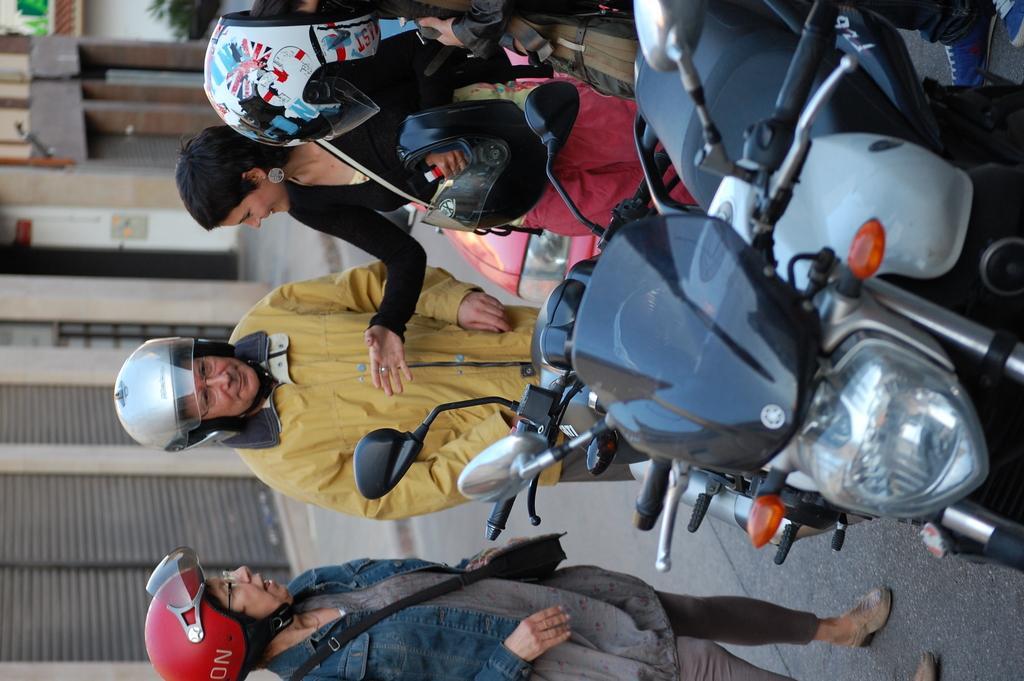Describe this image in one or two sentences. The picture consists of motorbikes and people wearing helmets. On the left it is blurred and there are buildings. 